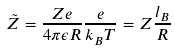<formula> <loc_0><loc_0><loc_500><loc_500>\tilde { Z } = \frac { Z e } { 4 \pi \epsilon R } \frac { e } { k _ { B } T } = Z \frac { l _ { B } } { R }</formula> 